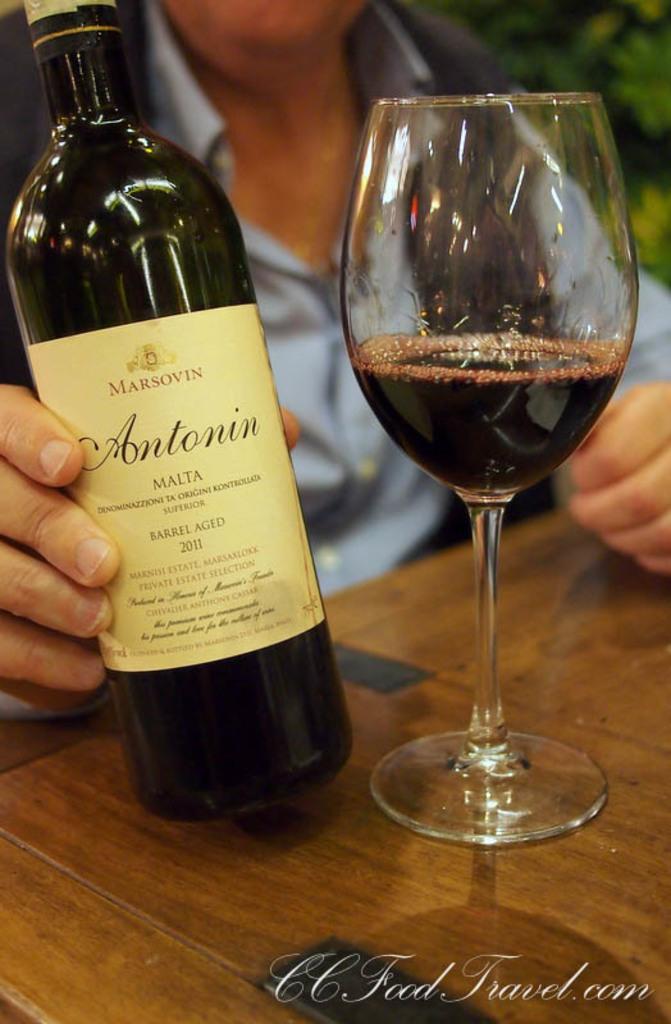Can you describe this image briefly? In this image we can see a bottle with label on it and a glass with a drink in it are placed on the wooden surface. Here we can see a person wearing shirt and the image is blurred. Here we can see the watermark on the bottom right side of the image. 